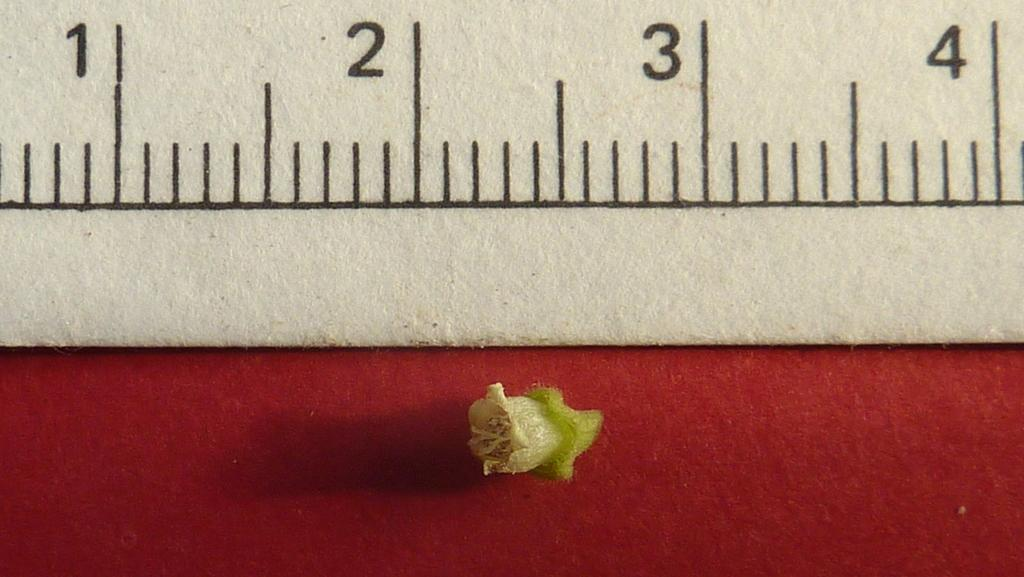<image>
Provide a brief description of the given image. White ruler that has the number up to 4 measuring an item. 